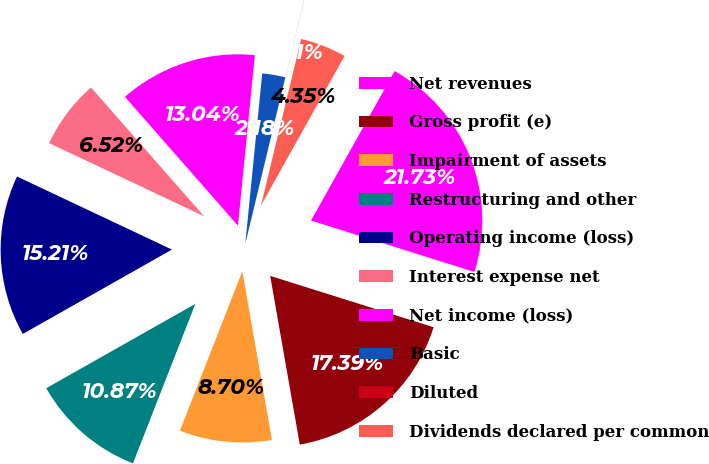<chart> <loc_0><loc_0><loc_500><loc_500><pie_chart><fcel>Net revenues<fcel>Gross profit (e)<fcel>Impairment of assets<fcel>Restructuring and other<fcel>Operating income (loss)<fcel>Interest expense net<fcel>Net income (loss)<fcel>Basic<fcel>Diluted<fcel>Dividends declared per common<nl><fcel>21.73%<fcel>17.39%<fcel>8.7%<fcel>10.87%<fcel>15.21%<fcel>6.52%<fcel>13.04%<fcel>2.18%<fcel>0.01%<fcel>4.35%<nl></chart> 